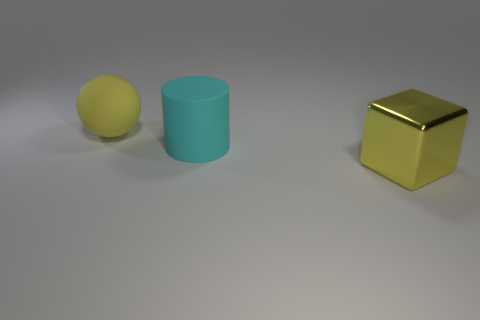Does the yellow thing that is behind the large yellow metal thing have the same size as the yellow thing in front of the yellow matte sphere? From the perspective of the image, it is somewhat challenging to compare the size of the two yellow objects due to differences in their distances from the viewpoint. However, judging by their relative dimensions and assuming no extreme distortions, it appears that the two yellow objects—the one behind the large yellow metal cube and the one in front of the yellow matte sphere—have similar sizes. This observation is based on the apparent uniformity in their design and proportion. 